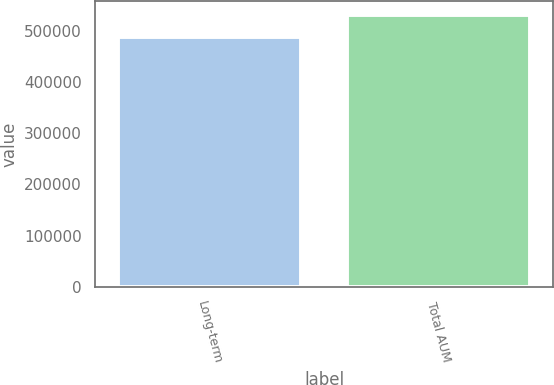<chart> <loc_0><loc_0><loc_500><loc_500><bar_chart><fcel>Long-term<fcel>Total AUM<nl><fcel>487777<fcel>532115<nl></chart> 